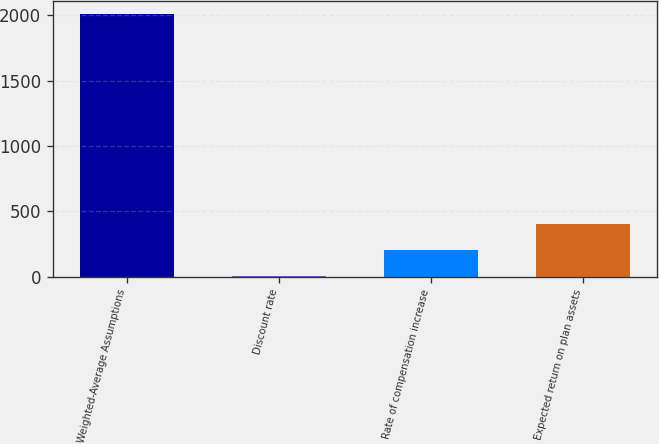Convert chart to OTSL. <chart><loc_0><loc_0><loc_500><loc_500><bar_chart><fcel>Weighted-Average Assumptions<fcel>Discount rate<fcel>Rate of compensation increase<fcel>Expected return on plan assets<nl><fcel>2012<fcel>3.83<fcel>204.65<fcel>405.47<nl></chart> 